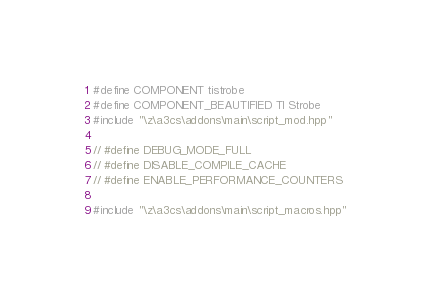<code> <loc_0><loc_0><loc_500><loc_500><_C++_>#define COMPONENT tistrobe
#define COMPONENT_BEAUTIFIED TI Strobe
#include "\z\a3cs\addons\main\script_mod.hpp"

// #define DEBUG_MODE_FULL
// #define DISABLE_COMPILE_CACHE
// #define ENABLE_PERFORMANCE_COUNTERS

#include "\z\a3cs\addons\main\script_macros.hpp"
</code> 